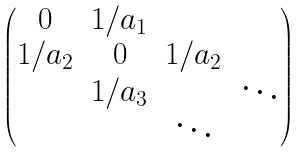<formula> <loc_0><loc_0><loc_500><loc_500>\begin{pmatrix} 0 & 1 / a _ { 1 } & & \\ 1 / a _ { 2 } & 0 & 1 / a _ { 2 } & \\ & 1 / a _ { 3 } & & \ddots \\ & & \ddots & \end{pmatrix}</formula> 